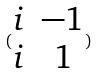Convert formula to latex. <formula><loc_0><loc_0><loc_500><loc_500>( \begin{matrix} i & - 1 \\ i & 1 \end{matrix} )</formula> 